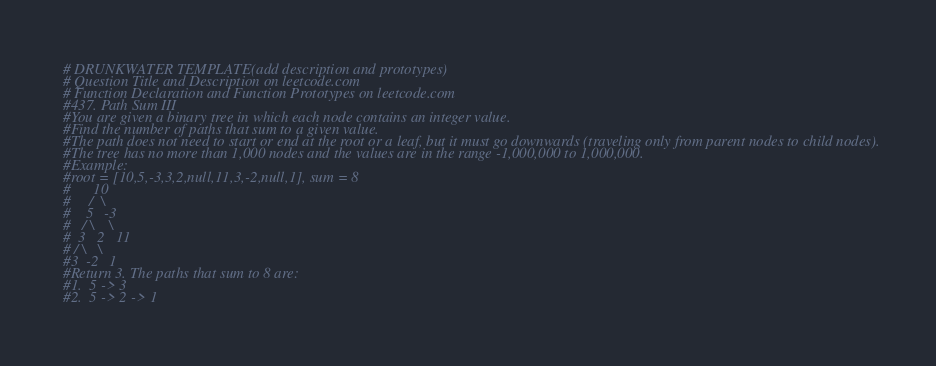Convert code to text. <code><loc_0><loc_0><loc_500><loc_500><_Python_># DRUNKWATER TEMPLATE(add description and prototypes)
# Question Title and Description on leetcode.com
# Function Declaration and Function Prototypes on leetcode.com
#437. Path Sum III
#You are given a binary tree in which each node contains an integer value.
#Find the number of paths that sum to a given value.
#The path does not need to start or end at the root or a leaf, but it must go downwards (traveling only from parent nodes to child nodes).
#The tree has no more than 1,000 nodes and the values are in the range -1,000,000 to 1,000,000.
#Example:
#root = [10,5,-3,3,2,null,11,3,-2,null,1], sum = 8
#      10
#     /  \
#    5   -3
#   / \    \
#  3   2   11
# / \   \
#3  -2   1
#Return 3. The paths that sum to 8 are:
#1.  5 -> 3
#2.  5 -> 2 -> 1</code> 